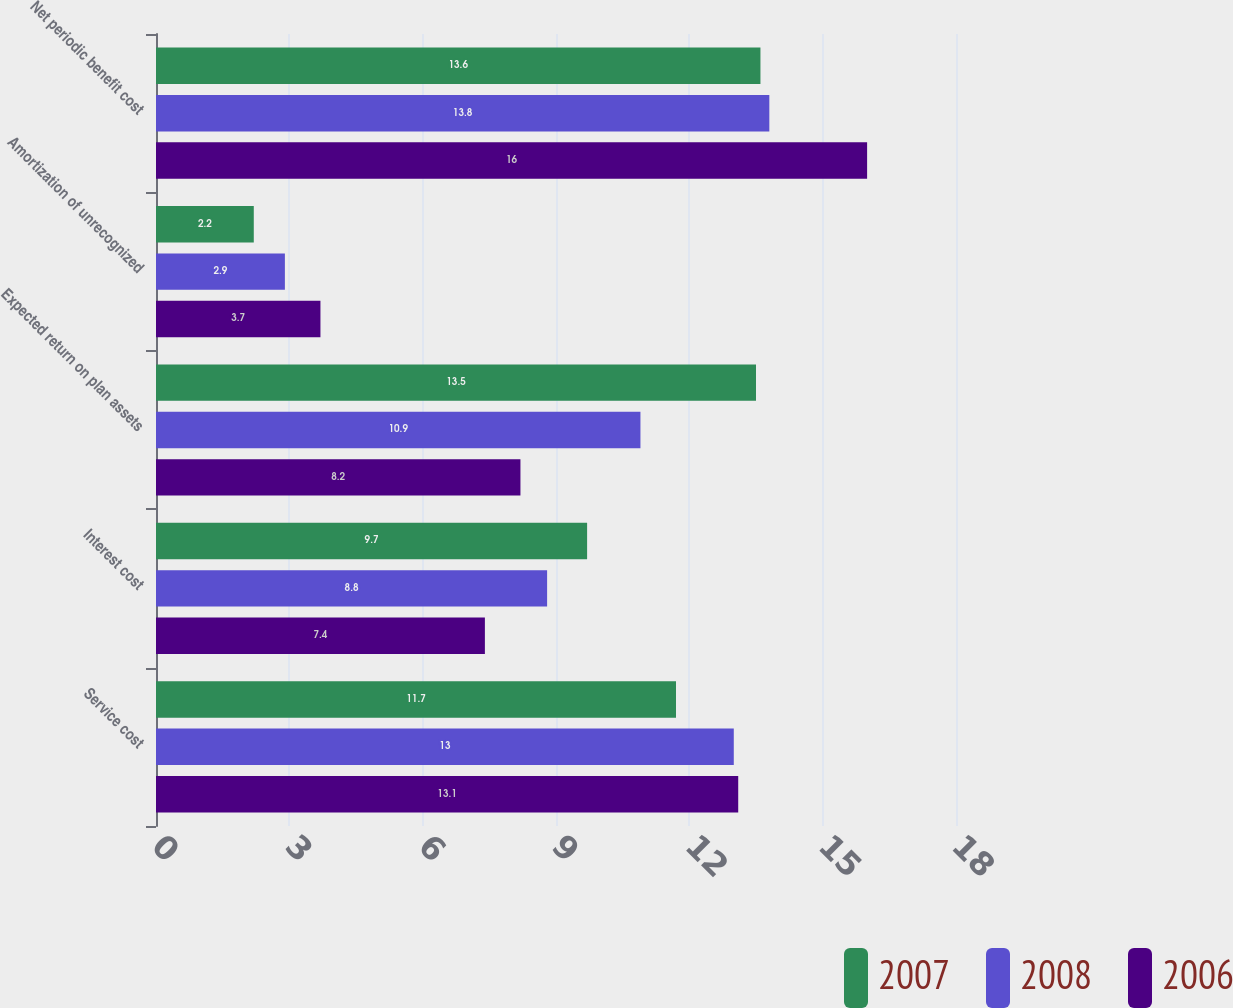Convert chart to OTSL. <chart><loc_0><loc_0><loc_500><loc_500><stacked_bar_chart><ecel><fcel>Service cost<fcel>Interest cost<fcel>Expected return on plan assets<fcel>Amortization of unrecognized<fcel>Net periodic benefit cost<nl><fcel>2007<fcel>11.7<fcel>9.7<fcel>13.5<fcel>2.2<fcel>13.6<nl><fcel>2008<fcel>13<fcel>8.8<fcel>10.9<fcel>2.9<fcel>13.8<nl><fcel>2006<fcel>13.1<fcel>7.4<fcel>8.2<fcel>3.7<fcel>16<nl></chart> 